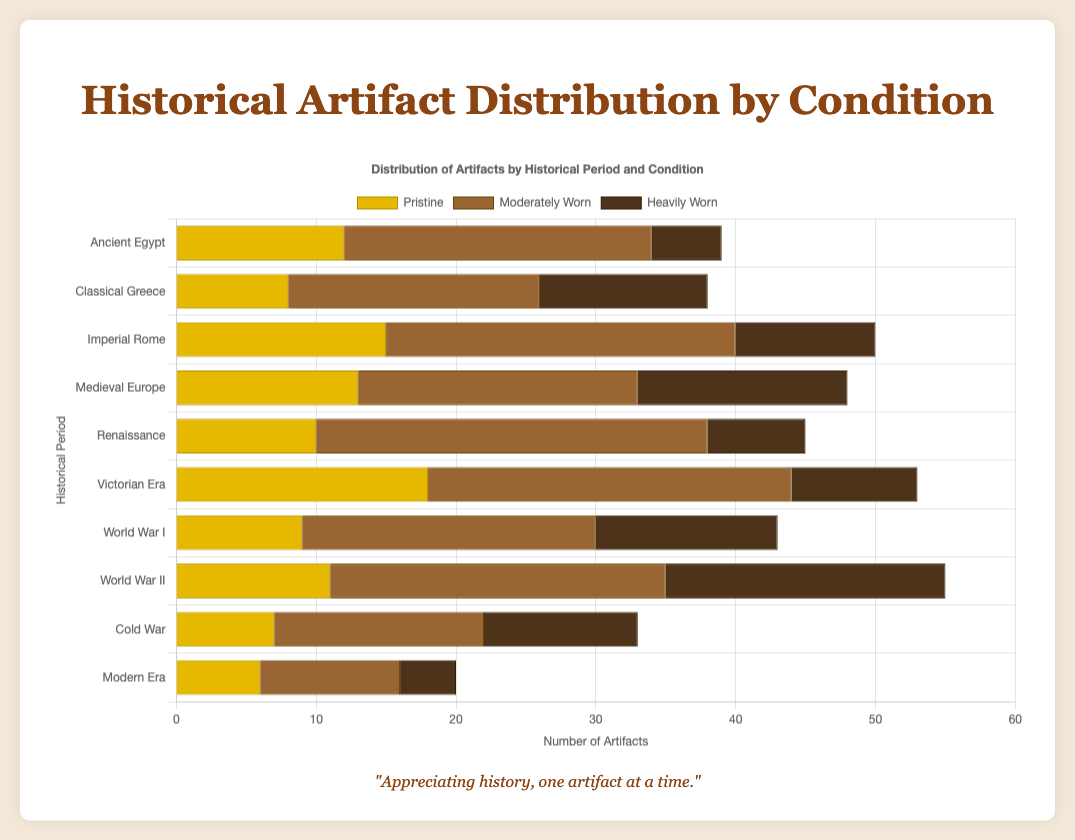Which historical period has the highest number of pristine artifacts? Look at the bar chart and identify the period with the longest bar for pristine artifacts. The Victorian Era has the longest bar.
Answer: Victorian Era Which historical period has the most artifacts in total? Sum the pristine, moderately worn, and heavily worn artifacts for each period. The period with the highest sum is the Renaissance with 45 artifacts.
Answer: Renaissance How many more moderately worn artifacts are there in Imperial Rome compared to Classical Greece? Calculate the difference between the moderately worn artifacts of Imperial Rome (25) and Classical Greece (18). 25 - 18 = 7.
Answer: 7 Which historical period has the smallest number of heavily worn artifacts? Look at the bars representing heavily worn artifacts and identify the period with the shortest bar. The Modern Era has the smallest number with 4 heavily worn artifacts.
Answer: Modern Era What is the total number of artifacts collected from World War I and World War II? Add the pristine, moderately worn, and heavily worn artifacts from both periods. World War I: 9 + 21 + 13 = 43, World War II: 11 + 24 + 20 = 55. 43 + 55 = 98.
Answer: 98 What is the ratio of pristine to heavily worn artifacts in Ancient Egypt? Divide the number of pristine artifacts by the number of heavily worn artifacts in Ancient Egypt. The pristine artifacts are 12, and heavily worn are 5. 12 / 5 is approximately 2.4.
Answer: 2.4 Which historical period has more moderately worn artifacts than Renaissance but fewer heavy worn artifacts than Medieval Europe? Identify periods with more moderately worn artifacts than the Renaissance (28) and fewer heavily worn than Medieval Europe (15). Victorian Era fits with 26 moderately worn and 9 heavily worn.
Answer: Victorian Era How many more pristine artifacts are there in Imperial Rome compared to Classical Greece and Modern Era combined? Add pristine artifacts of Classical Greece (8) and Modern Era (6) and then subtract from Imperial Rome. 8 + 6 = 14, Imperial Rome: 15. 15 - 14 = 1.
Answer: 1 